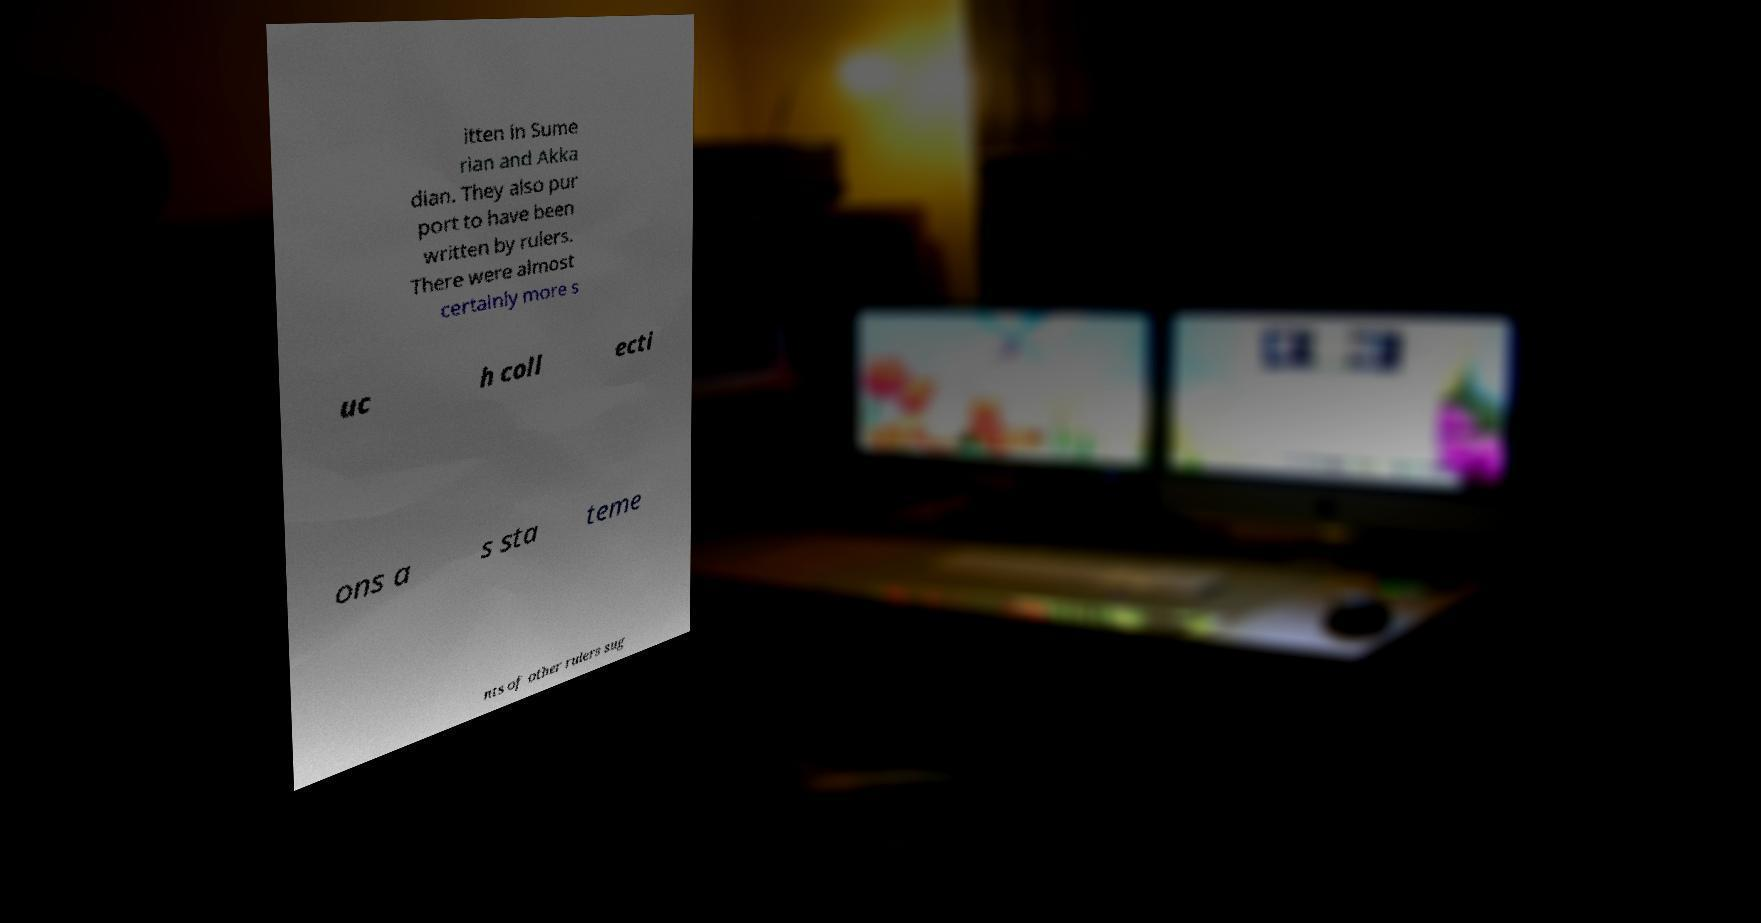Can you read and provide the text displayed in the image?This photo seems to have some interesting text. Can you extract and type it out for me? itten in Sume rian and Akka dian. They also pur port to have been written by rulers. There were almost certainly more s uc h coll ecti ons a s sta teme nts of other rulers sug 